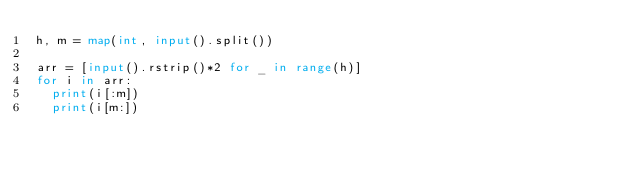Convert code to text. <code><loc_0><loc_0><loc_500><loc_500><_Python_>h, m = map(int, input().split())

arr = [input().rstrip()*2 for _ in range(h)]
for i in arr:
  print(i[:m])
  print(i[m:])</code> 